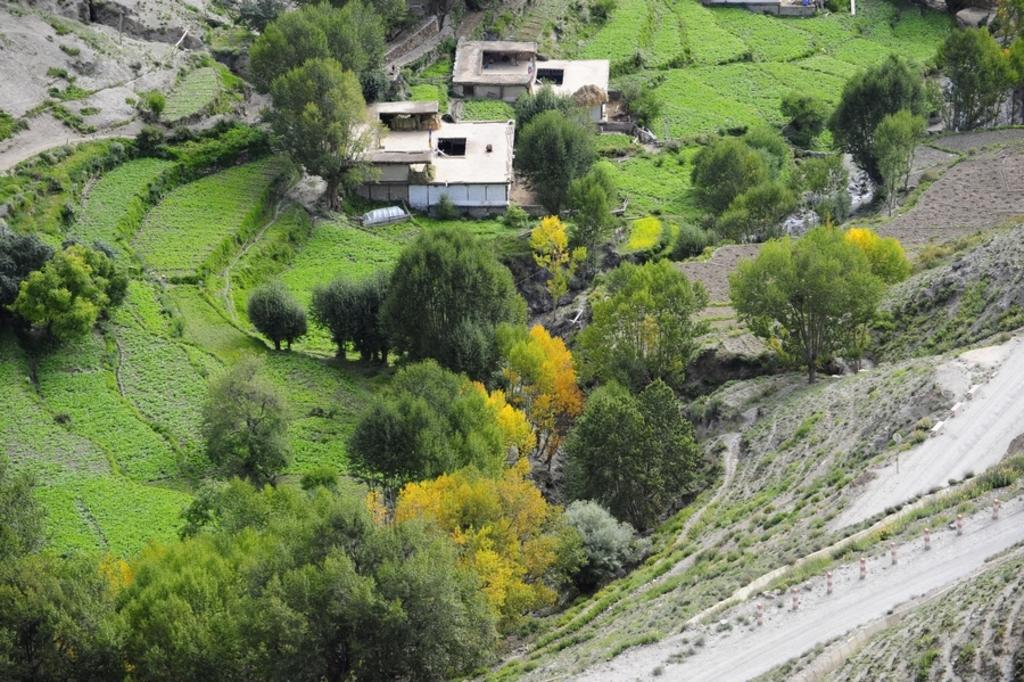What perspective is used to capture the image? The image is taken from a top view. What can be seen at the bottom of the image? There are many trees and plants at the bottom of the image. What is the color of the grass in the image? The grass on the ground is green. How many houses are visible in the image? There are two houses in the middle of the image. What type of locket is hanging from the tree in the image? There is no locket hanging from a tree in the image. Can you tell me how many bones are scattered on the ground in the image? There are no bones visible on the ground in the image. 